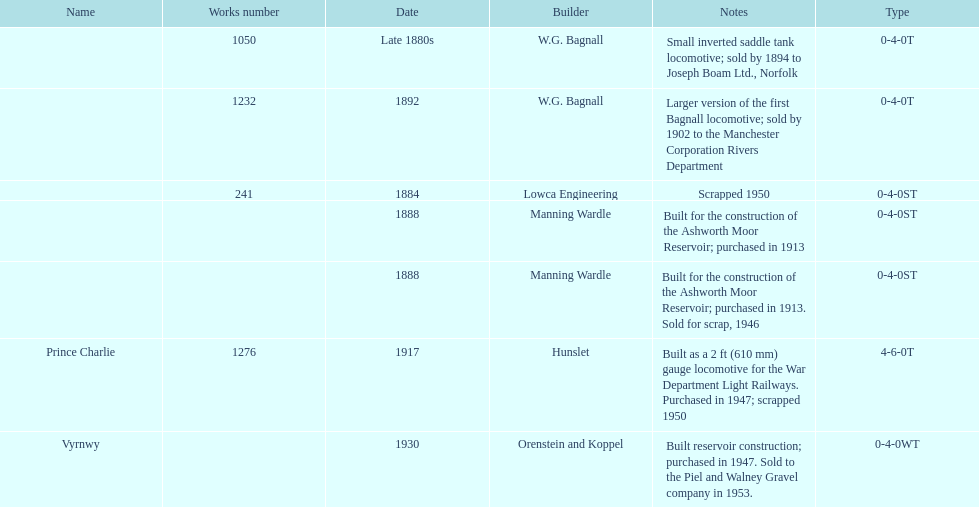List each of the builder's that had a locomotive scrapped. Lowca Engineering, Manning Wardle, Hunslet. 